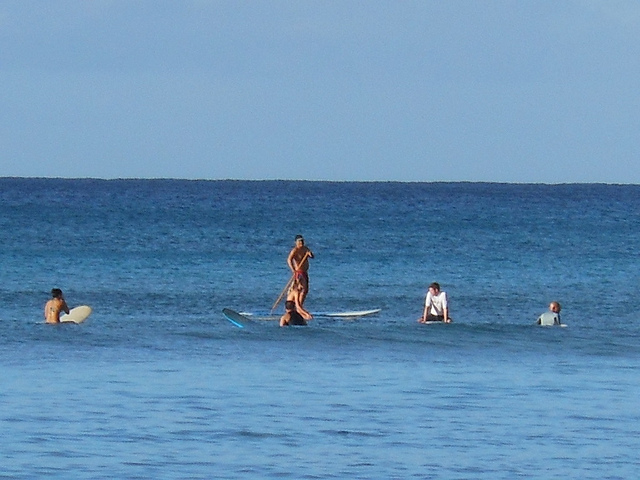What kind of water activity are the individuals in the image participating in? The individuals are engaged in varying water activities. The central figure is stand-up paddleboarding, a popular surface water sport. The person to the left appears to be surfing, waiting for a wave to ride, and the individuals to the right seem to be learning to surf, as they are closer to the shore and one appears to be instructed by a potential surf instructor. 